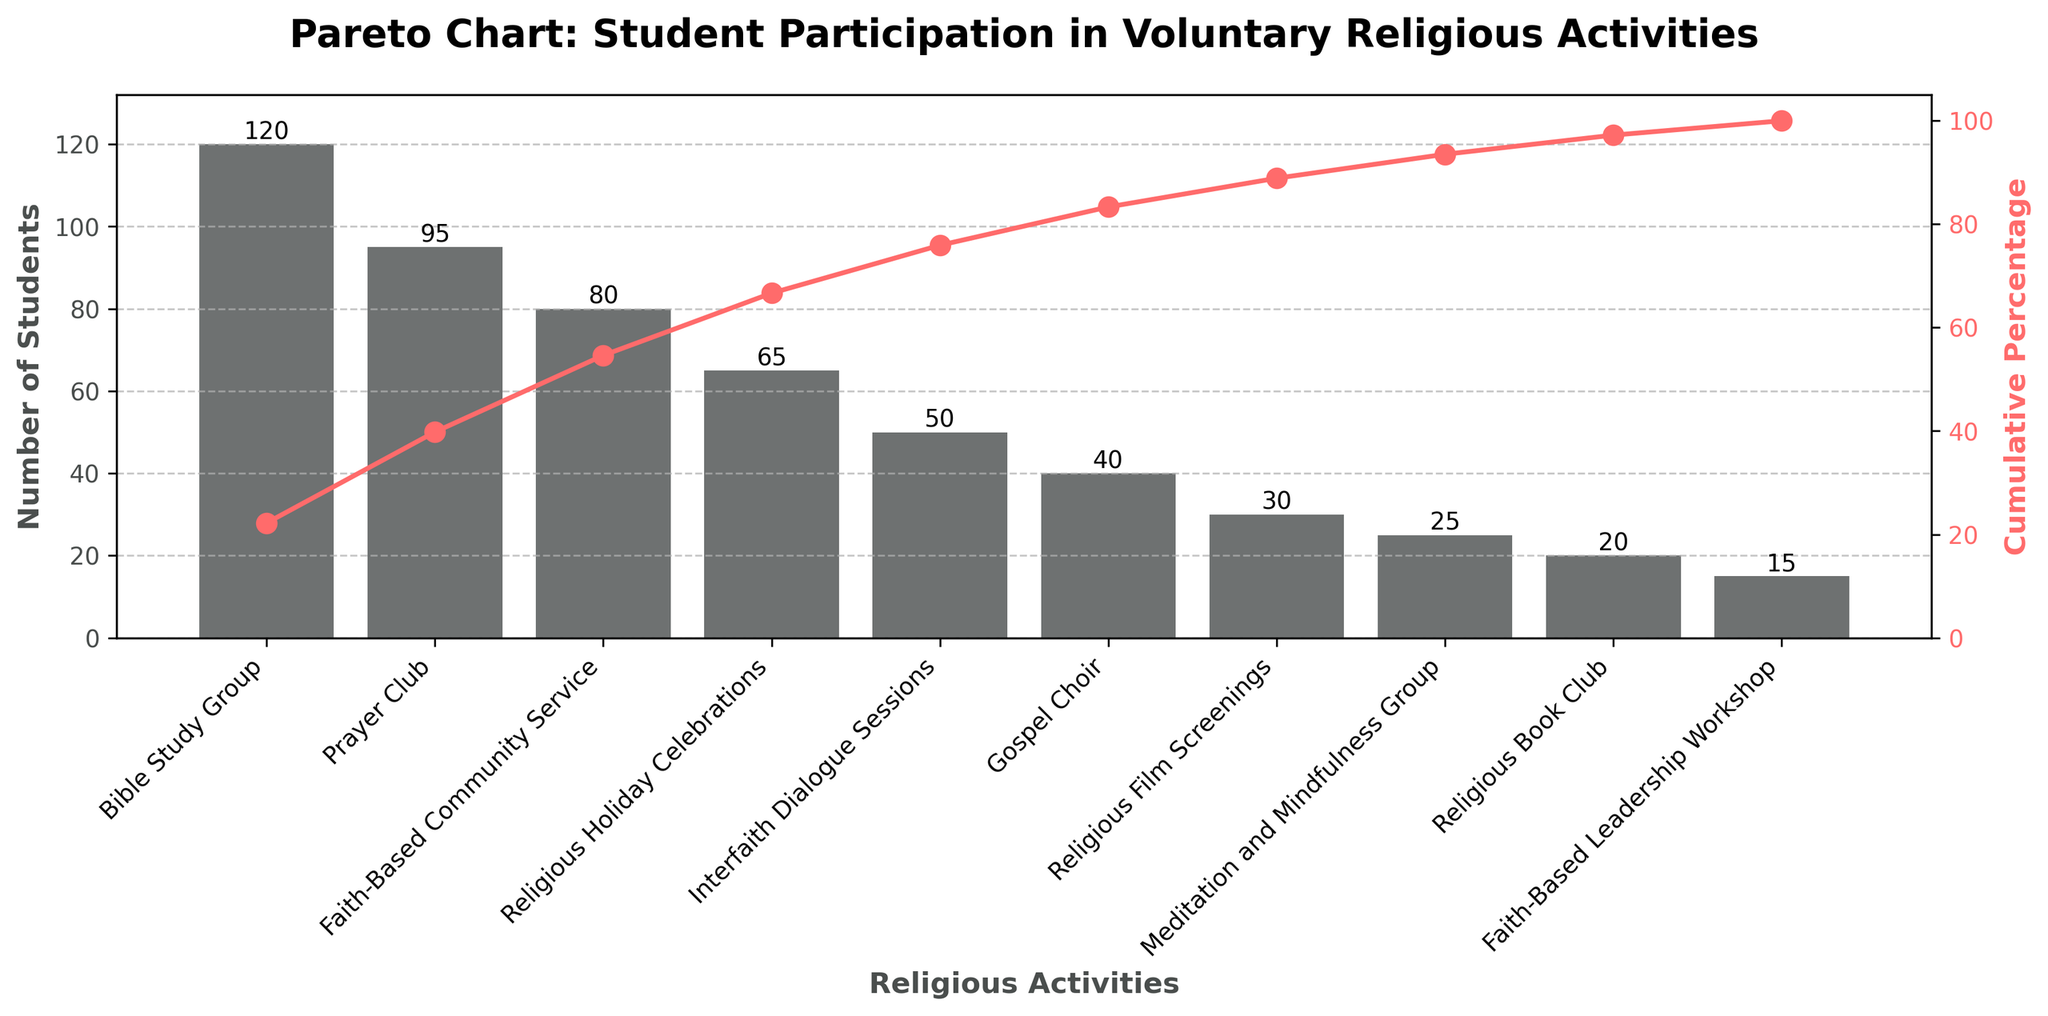what is the title of the chart? The title is usually located at the top of the chart and provides a summary of what the chart is about. Here, the title reads: "Pareto Chart: Student Participation in Voluntary Religious Activities."
Answer: Pareto Chart: Student Participation in Voluntary Religious Activities how many activities are listed in the chart? Count the number of distinct bars or points plotted on the x-axis, each representing a different activity.
Answer: 10 which activity has the highest number of participating students? The tallest bar in the bar chart represents the activity with the highest number of participating students. Here, it is the "Bible Study Group."
Answer: Bible Study Group which activity has the lowest number of participating students? The shortest bar in the bar chart represents the activity with the lowest number of participating students. Here, it is the "Faith-Based Leadership Workshop."
Answer: Faith-Based Leadership Workshop what percentage of student participation is achieved by the top three activities? To find this, look at the cumulative percentage line and identify the cumulative percentage after the third activity ("Faith-Based Community Service "). According to the chart, it’s around 75%.
Answer: 75% how many students participate in gospel choir? Find the bar labeled "Gospel Choir" and read the value on the y-axis or on top of the bar. It shows 40 students.
Answer: 40 how much more popular is the bible study group compared to the interfaith dialogue sessions? Compare the bars for "Bible Study Group" (120 students) and "Interfaith Dialogue Sessions" (50 students). Subtract the smaller value from the larger one: 120 - 50 = 70.
Answer: 70 what is the cumulative percentage after the fifth activity? Look at the cumulative percentage line corresponding to the fifth activity (Interfaith Dialogue Sessions). It is approximately 85%.
Answer: 85% how many students in total participate in faith-based community service and prayers club? Add the number of students for "Faith-Based Community Service " (80) and "Prayer Club" (95): 80 + 95 = 175.
Answer: 175 what is the color of the cumulative percentage line? The line for the cumulative percentage is drawn in a color different from the bars. In this case, it is red.
Answer: red which activity marks the transition above 50% cumulative percentage? Identify the activity where the cumulative percentage line crosses the 50% mark. This occurs at the "Prayer Club" activity.
Answer: Prayer Club 